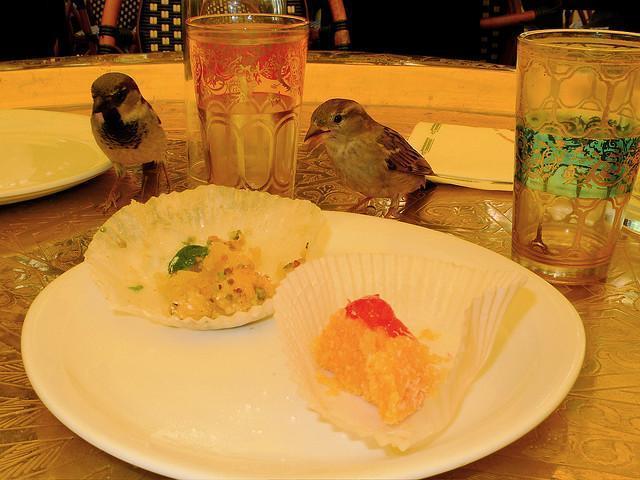How many birds are on the table?
Give a very brief answer. 2. How many glasses do you see?
Give a very brief answer. 2. How many cups are there?
Give a very brief answer. 2. How many birds are visible?
Give a very brief answer. 2. How many pizzas are in boxes?
Give a very brief answer. 0. 